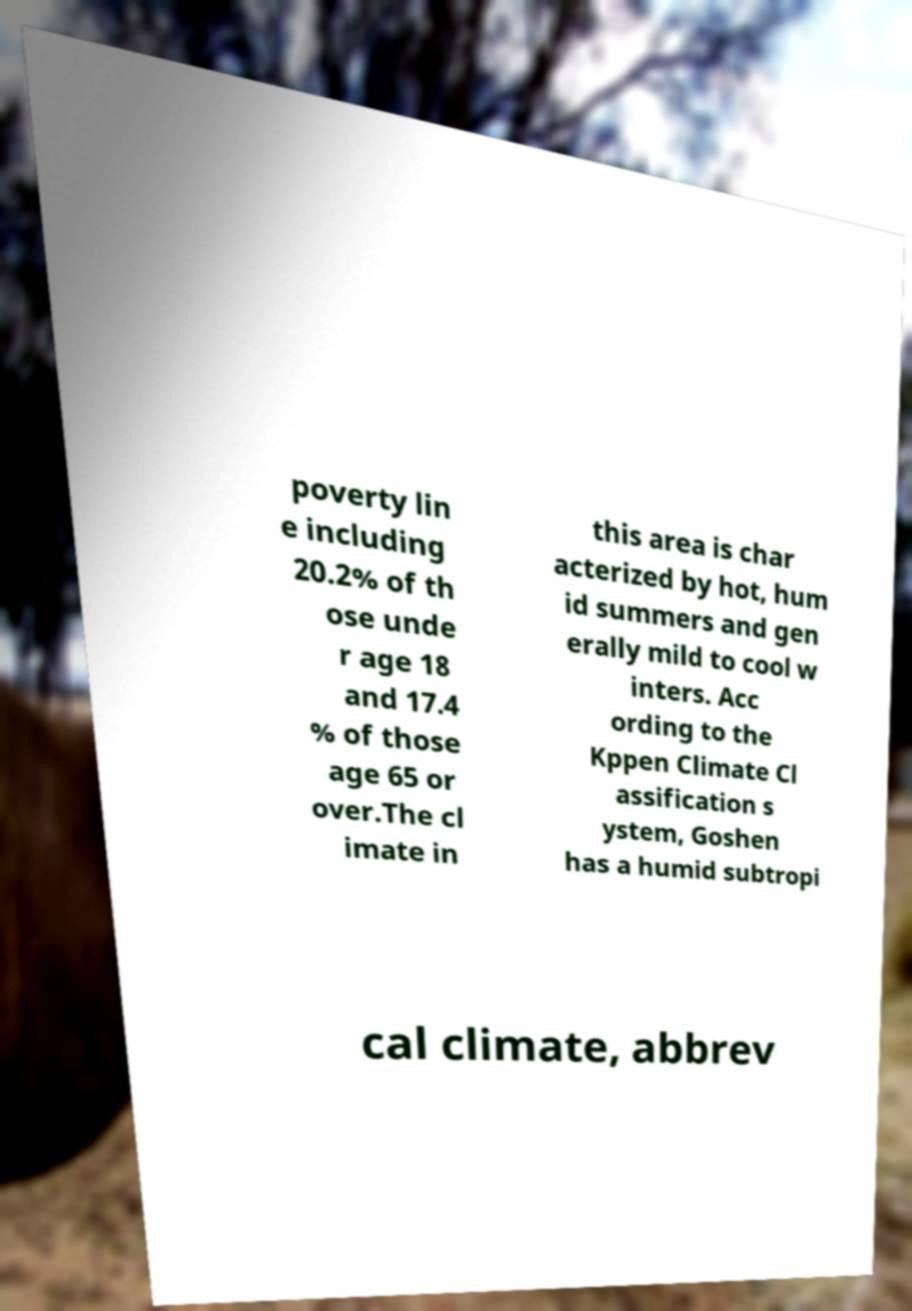Please identify and transcribe the text found in this image. poverty lin e including 20.2% of th ose unde r age 18 and 17.4 % of those age 65 or over.The cl imate in this area is char acterized by hot, hum id summers and gen erally mild to cool w inters. Acc ording to the Kppen Climate Cl assification s ystem, Goshen has a humid subtropi cal climate, abbrev 